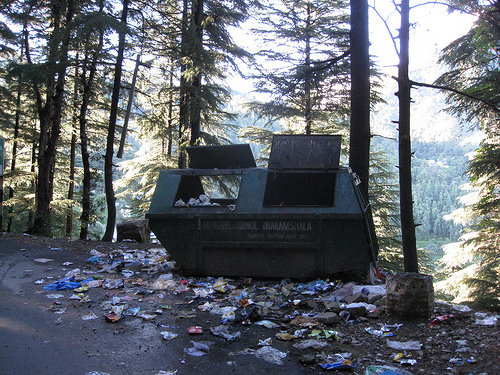<image>
Can you confirm if the tree is behind the dumpster? Yes. From this viewpoint, the tree is positioned behind the dumpster, with the dumpster partially or fully occluding the tree. 